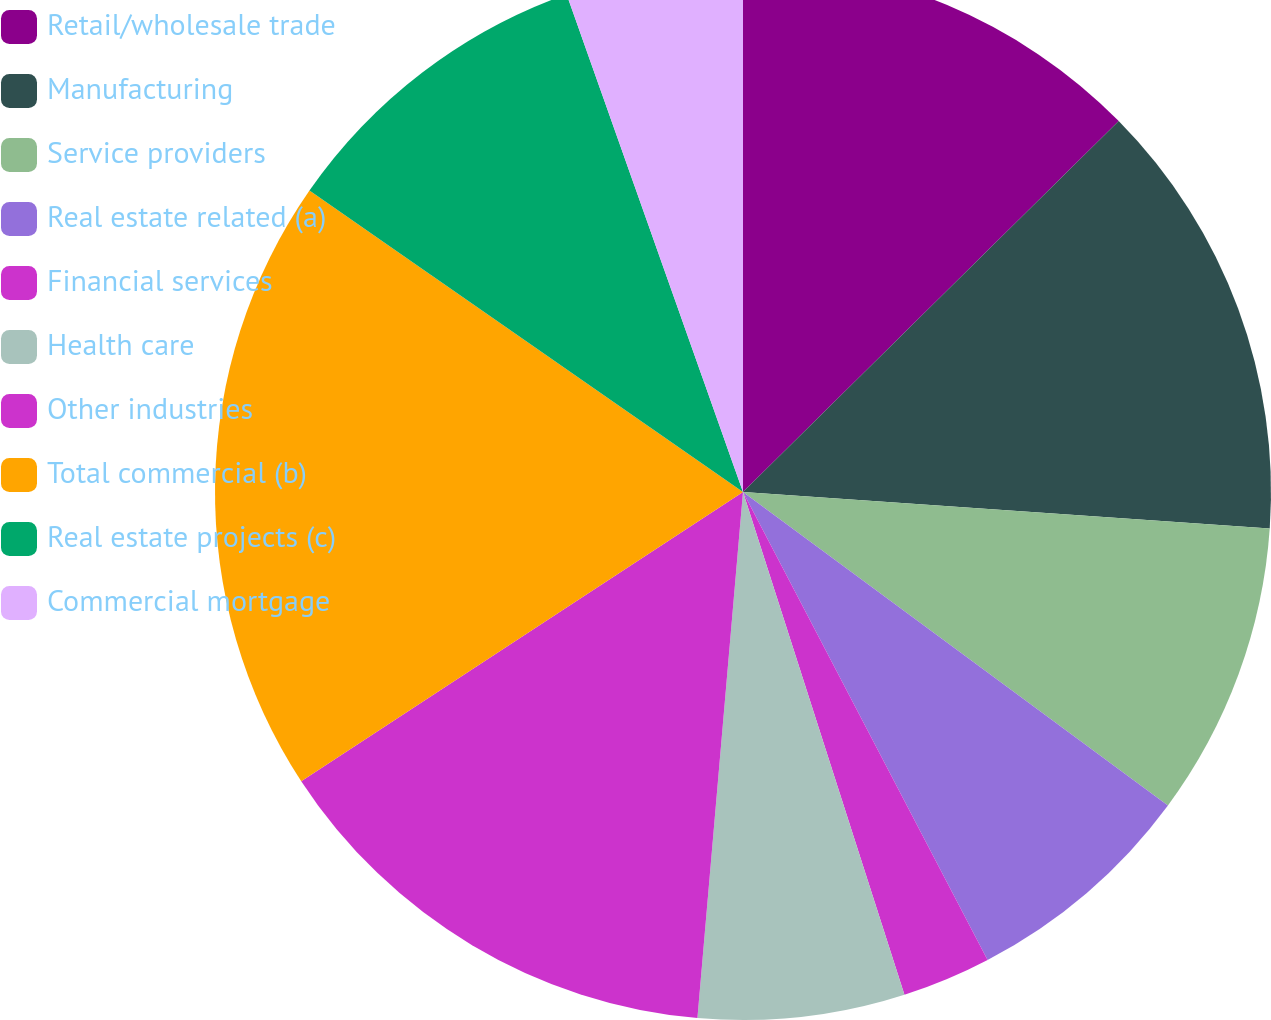Convert chart. <chart><loc_0><loc_0><loc_500><loc_500><pie_chart><fcel>Retail/wholesale trade<fcel>Manufacturing<fcel>Service providers<fcel>Real estate related (a)<fcel>Financial services<fcel>Health care<fcel>Other industries<fcel>Total commercial (b)<fcel>Real estate projects (c)<fcel>Commercial mortgage<nl><fcel>12.6%<fcel>13.5%<fcel>9.01%<fcel>7.22%<fcel>2.72%<fcel>6.32%<fcel>14.4%<fcel>18.89%<fcel>9.91%<fcel>5.42%<nl></chart> 